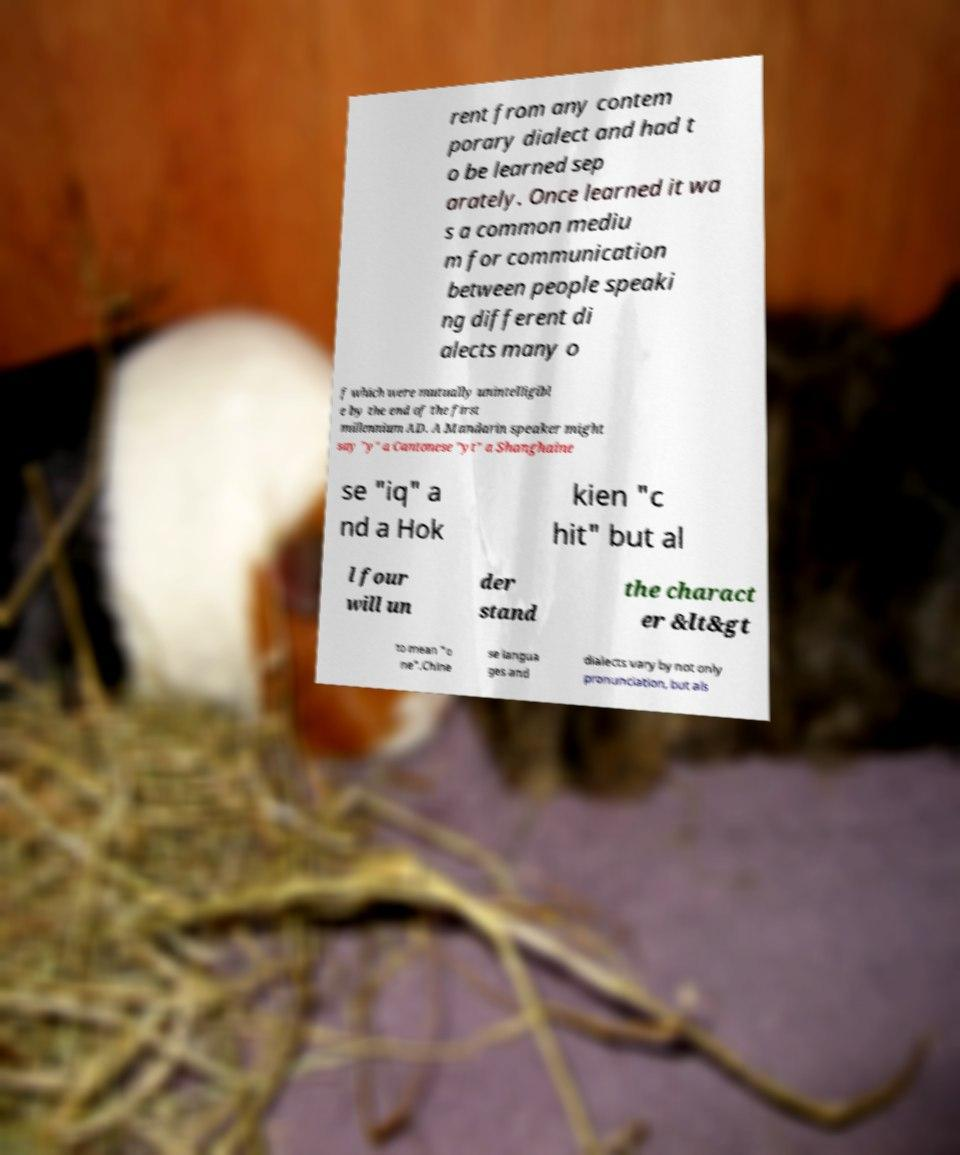I need the written content from this picture converted into text. Can you do that? rent from any contem porary dialect and had t o be learned sep arately. Once learned it wa s a common mediu m for communication between people speaki ng different di alects many o f which were mutually unintelligibl e by the end of the first millennium AD. A Mandarin speaker might say "y" a Cantonese "yt" a Shanghaine se "iq" a nd a Hok kien "c hit" but al l four will un der stand the charact er &lt&gt to mean "o ne".Chine se langua ges and dialects vary by not only pronunciation, but als 